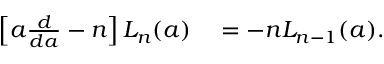Convert formula to latex. <formula><loc_0><loc_0><loc_500><loc_500>\begin{array} { r l } { \left [ a \frac { d } { d a } - n \right ] L _ { n } ( a ) } & = - n L _ { n - 1 } ( a ) . } \end{array}</formula> 